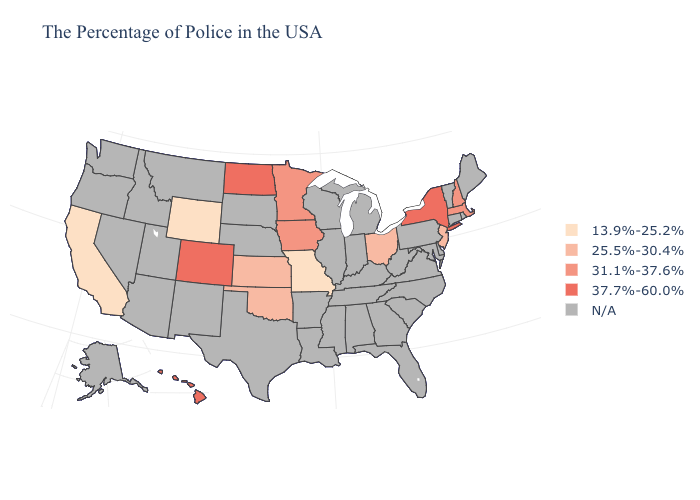What is the highest value in the USA?
Quick response, please. 37.7%-60.0%. Does the first symbol in the legend represent the smallest category?
Write a very short answer. Yes. Name the states that have a value in the range 31.1%-37.6%?
Concise answer only. Massachusetts, New Hampshire, Minnesota, Iowa. Which states have the lowest value in the USA?
Concise answer only. Missouri, Wyoming, California. Name the states that have a value in the range 37.7%-60.0%?
Short answer required. New York, North Dakota, Colorado, Hawaii. What is the value of North Carolina?
Keep it brief. N/A. Does Ohio have the lowest value in the USA?
Keep it brief. No. What is the lowest value in the USA?
Be succinct. 13.9%-25.2%. Among the states that border Tennessee , which have the lowest value?
Keep it brief. Missouri. Name the states that have a value in the range 25.5%-30.4%?
Answer briefly. New Jersey, Ohio, Kansas, Oklahoma. Which states have the highest value in the USA?
Keep it brief. New York, North Dakota, Colorado, Hawaii. What is the value of Iowa?
Short answer required. 31.1%-37.6%. 